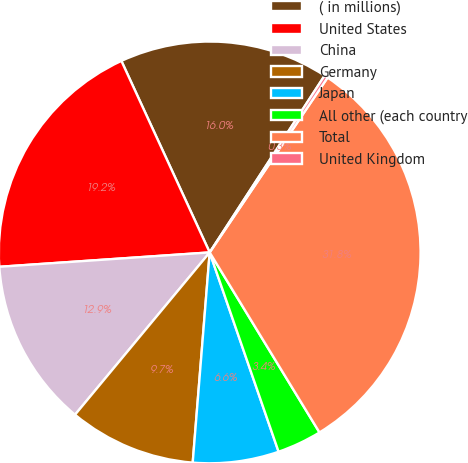Convert chart. <chart><loc_0><loc_0><loc_500><loc_500><pie_chart><fcel>( in millions)<fcel>United States<fcel>China<fcel>Germany<fcel>Japan<fcel>All other (each country<fcel>Total<fcel>United Kingdom<nl><fcel>16.05%<fcel>19.21%<fcel>12.89%<fcel>9.74%<fcel>6.58%<fcel>3.42%<fcel>31.84%<fcel>0.27%<nl></chart> 